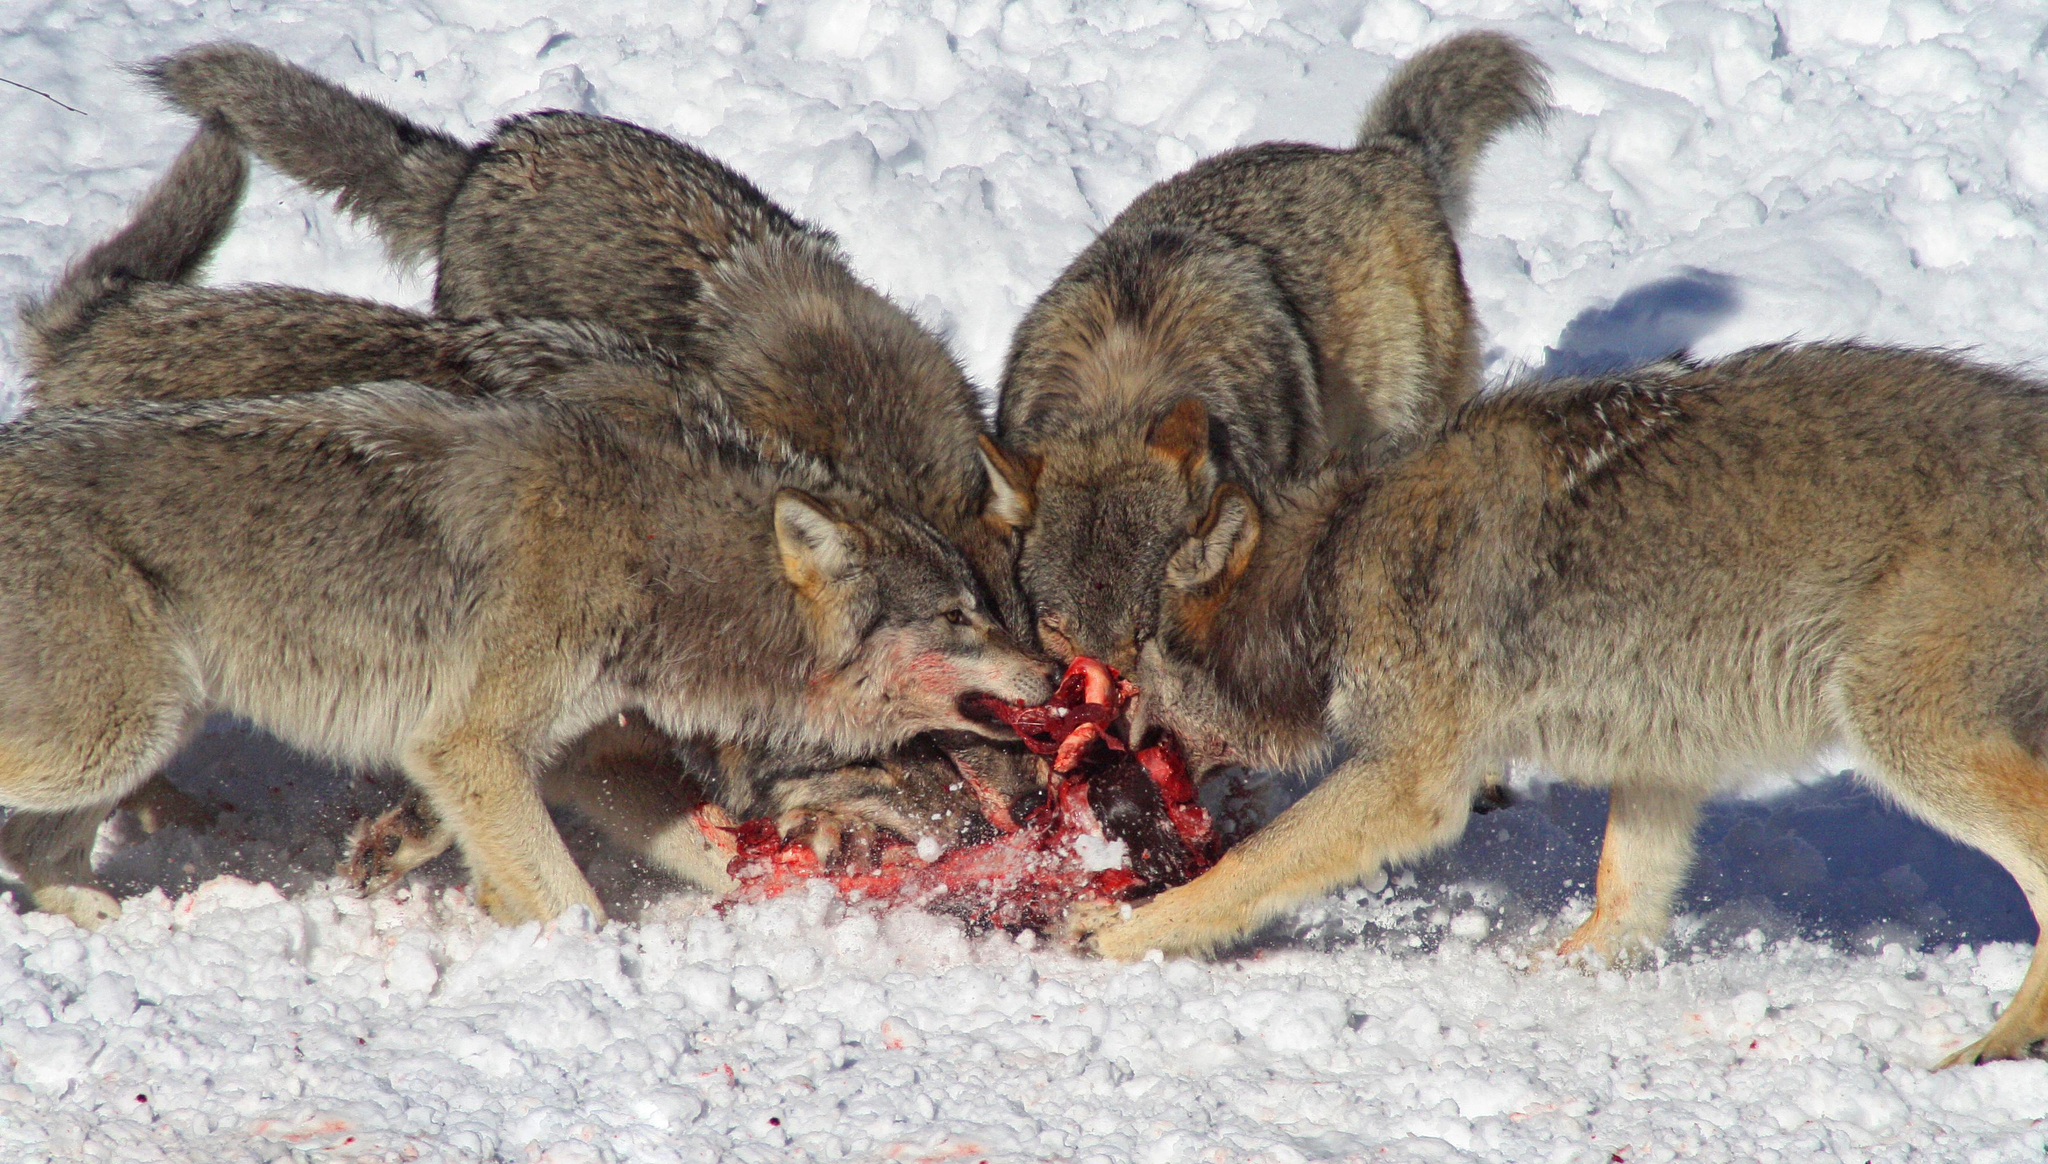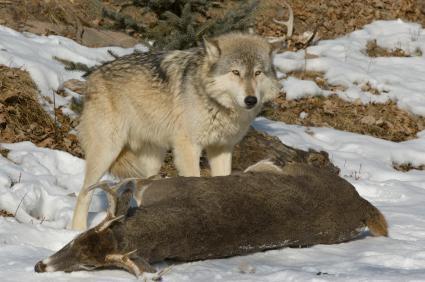The first image is the image on the left, the second image is the image on the right. Analyze the images presented: Is the assertion "All of the wolves are out in the snow." valid? Answer yes or no. Yes. The first image is the image on the left, the second image is the image on the right. For the images displayed, is the sentence "There's no more than two wolves in the right image." factually correct? Answer yes or no. Yes. 